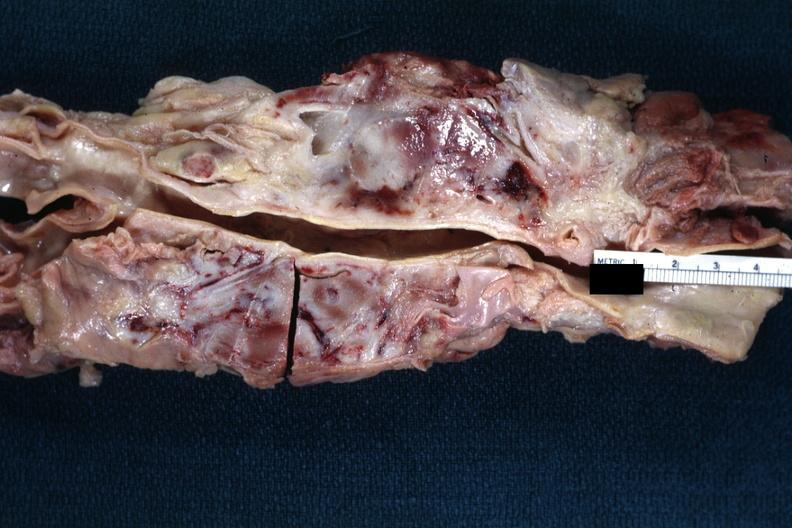what is present?
Answer the question using a single word or phrase. Malignant lymphoma 